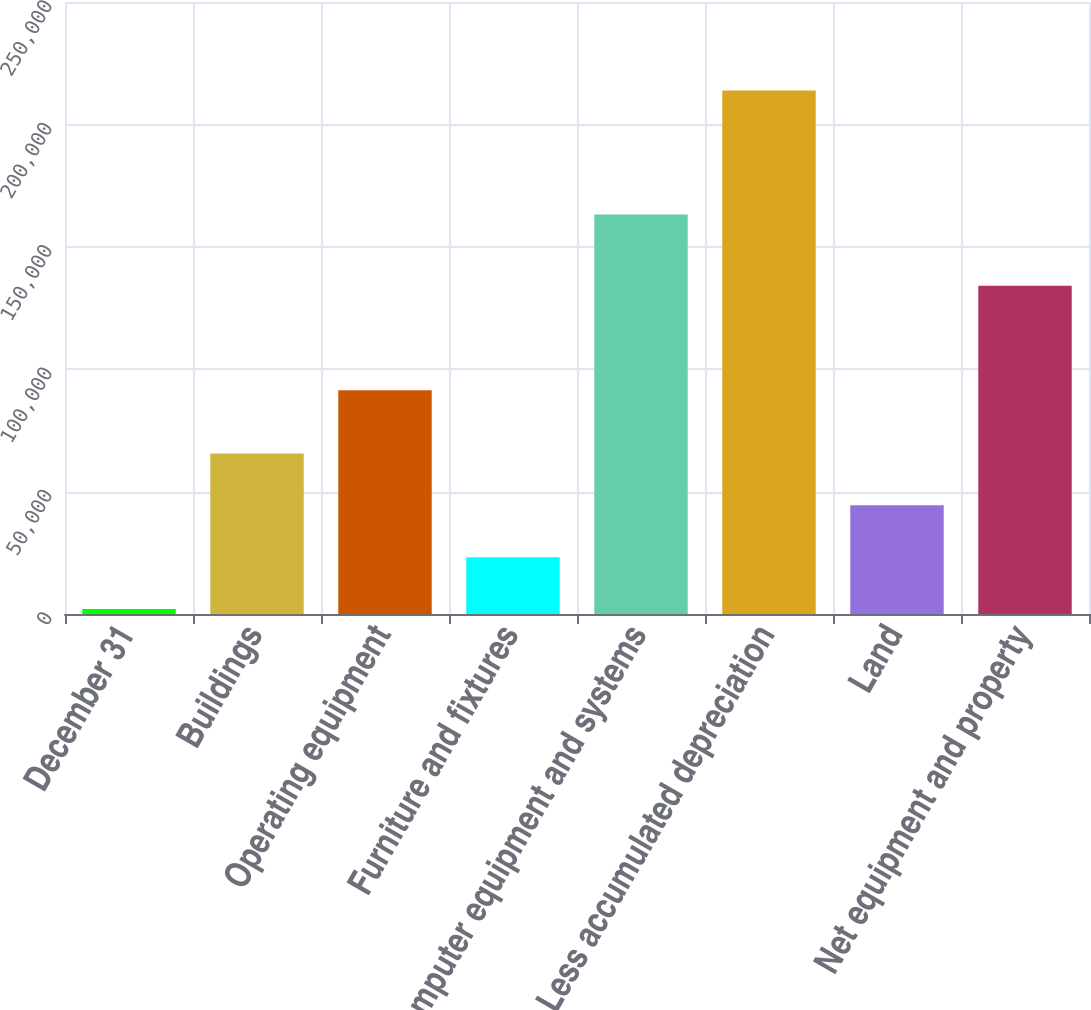<chart> <loc_0><loc_0><loc_500><loc_500><bar_chart><fcel>December 31<fcel>Buildings<fcel>Operating equipment<fcel>Furniture and fixtures<fcel>Computer equipment and systems<fcel>Less accumulated depreciation<fcel>Land<fcel>Net equipment and property<nl><fcel>2017<fcel>65554.6<fcel>91430<fcel>23196.2<fcel>163220<fcel>213809<fcel>44375.4<fcel>134088<nl></chart> 